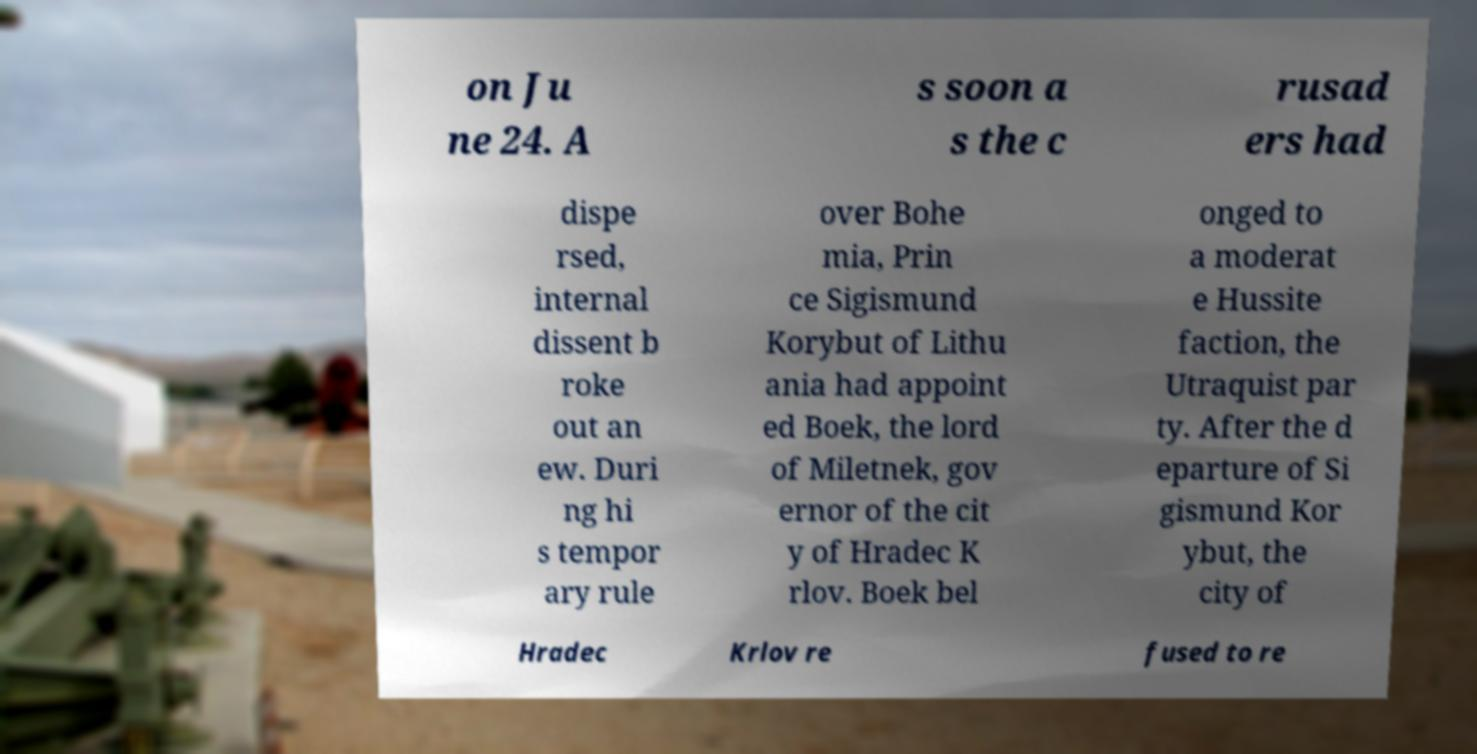There's text embedded in this image that I need extracted. Can you transcribe it verbatim? on Ju ne 24. A s soon a s the c rusad ers had dispe rsed, internal dissent b roke out an ew. Duri ng hi s tempor ary rule over Bohe mia, Prin ce Sigismund Korybut of Lithu ania had appoint ed Boek, the lord of Miletnek, gov ernor of the cit y of Hradec K rlov. Boek bel onged to a moderat e Hussite faction, the Utraquist par ty. After the d eparture of Si gismund Kor ybut, the city of Hradec Krlov re fused to re 